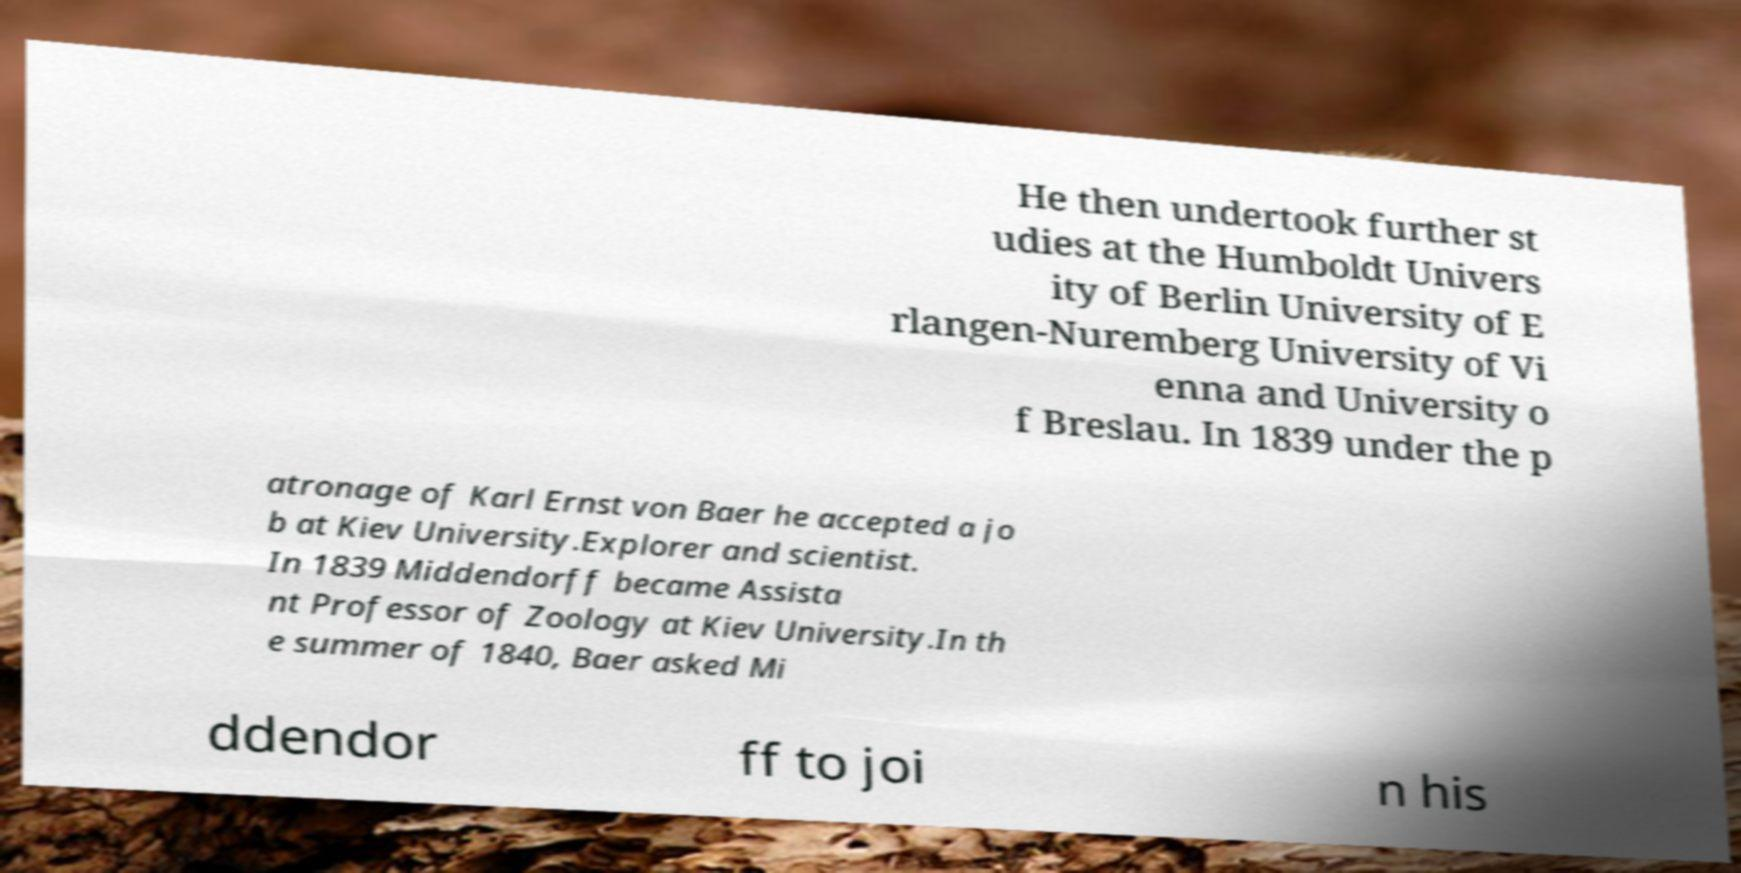There's text embedded in this image that I need extracted. Can you transcribe it verbatim? He then undertook further st udies at the Humboldt Univers ity of Berlin University of E rlangen-Nuremberg University of Vi enna and University o f Breslau. In 1839 under the p atronage of Karl Ernst von Baer he accepted a jo b at Kiev University.Explorer and scientist. In 1839 Middendorff became Assista nt Professor of Zoology at Kiev University.In th e summer of 1840, Baer asked Mi ddendor ff to joi n his 